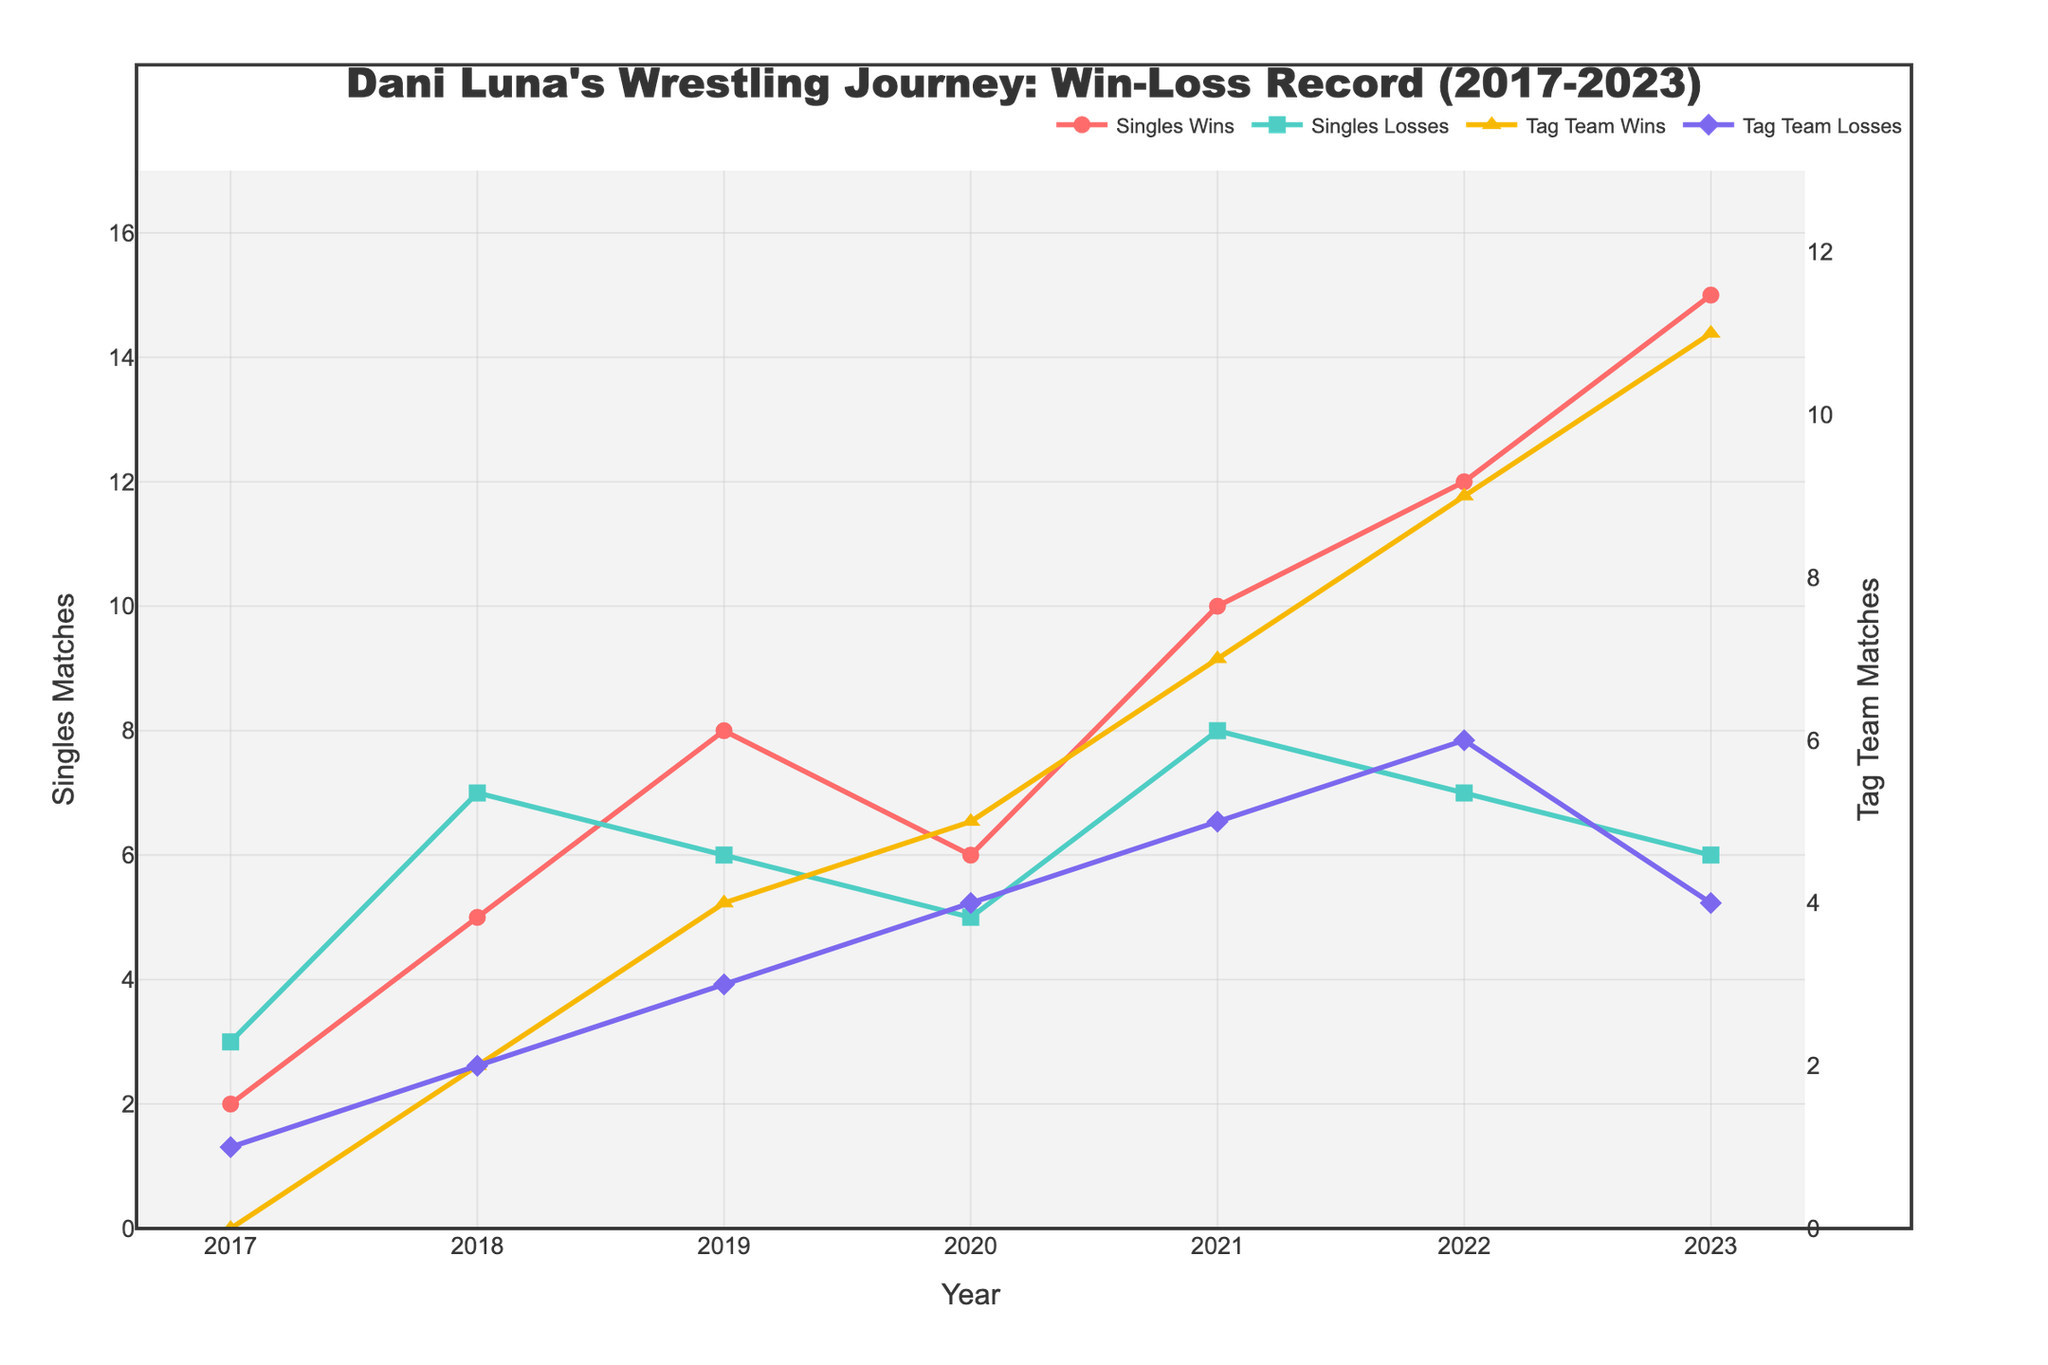What year did Dani Luna have the highest number of singles wins? Look at the line labeled "Singles Wins". The year with the highest peak is 2023, with 15 singles wins.
Answer: 2023 What is the total number of tag team wins and losses in 2020? Sum the tag team wins and tag team losses for 2020. The values are 5 wins and 4 losses. Therefore, 5 + 4 = 9.
Answer: 9 Between 2019 and 2021, did Dani Luna have more singles wins or tag team wins? Sum the singles wins from 2019 to 2021 (8 + 6 + 10) which equals 24, and tag team wins from 2019 to 2021 (4 + 5 + 7) which equals 16. 24 singles wins are greater than 16 tag team wins.
Answer: Singles Wins How did Dani Luna's losses in singles matches change from 2018 to 2023? Compare the values for singles losses from 2018 to 2023. The values are 7 (2018), 6 (2019), 5 (2020), 8 (2021), 7 (2022), and 6 (2023). It decreased to 6 in 2019 and 5 in 2020, increased to 8 in 2021, then decreased to 7 in 2022, and finally to 6 in 2023.
Answer: Overall, decreased from 7 to 6 In which year did Dani Luna have an equal number of tag team wins and losses, and what are those numbers? Look at the lines for "Tag Team Wins" and "Tag Team Losses". In 2018, both lines intersect at 2 wins and 2 losses.
Answer: 2018, 2 wins and 2 losses Which type of match saw the largest increase in wins from 2018 to 2023? Calculate the increase in wins for singles (15 in 2023 - 5 in 2018 = 10) and for tag team (11 in 2023 - 2 in 2018 = 9). Singles matches saw the largest increase of 10 wins.
Answer: Singles Matches What is the difference between singles wins and tag team wins in 2023? Subtract tag team wins from singles wins for 2023. The values are 15 singles wins and 11 tag team wins. Therefore, 15 - 11 = 4.
Answer: 4 Does Dani Luna have a higher win rate in singles or tag team matches in 2021? For singles in 2021: 10 wins over (10 wins + 8 losses) = 10/18 ≈ 55.56%. For tag teams in 2021: 7 wins over (7 wins + 5 losses) = 7/12 ≈ 58.33%. Thus, the win rate is higher for tag team matches.
Answer: Tag Team Matches Which year had the highest combined total of wins (both singles and tag team)? Sum the singles and tag team wins for each year and compare. The total wins in 2023 are 15 (singles) + 11 (tag teams) = 26, which is the highest.
Answer: 2023 